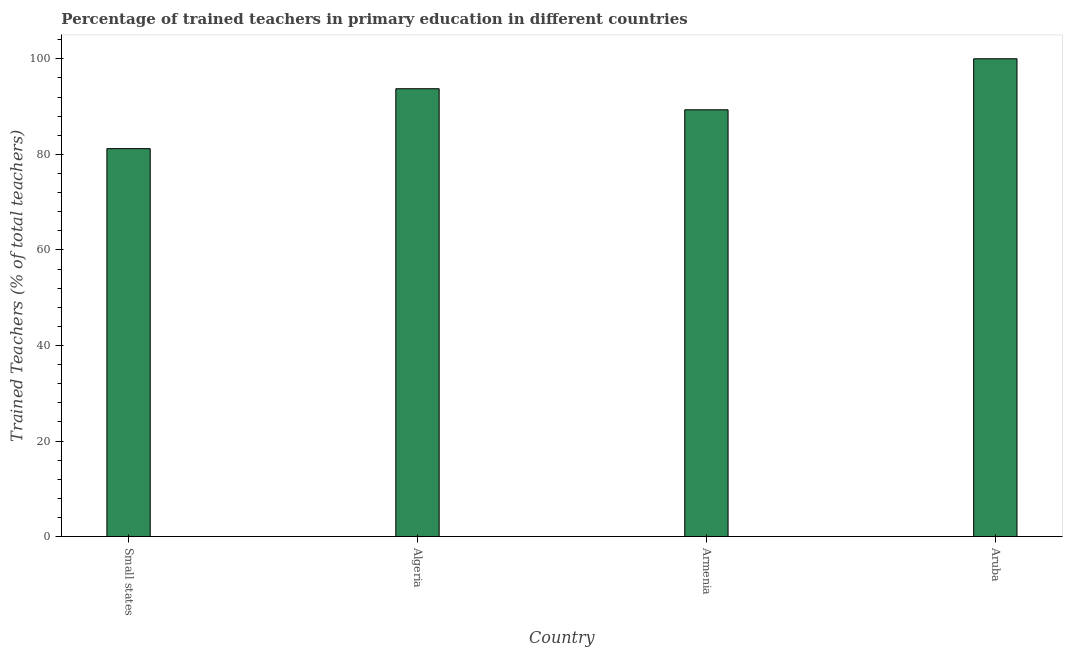Does the graph contain grids?
Your answer should be very brief. No. What is the title of the graph?
Offer a terse response. Percentage of trained teachers in primary education in different countries. What is the label or title of the Y-axis?
Ensure brevity in your answer.  Trained Teachers (% of total teachers). What is the percentage of trained teachers in Armenia?
Offer a very short reply. 89.33. Across all countries, what is the minimum percentage of trained teachers?
Make the answer very short. 81.19. In which country was the percentage of trained teachers maximum?
Offer a terse response. Aruba. In which country was the percentage of trained teachers minimum?
Offer a terse response. Small states. What is the sum of the percentage of trained teachers?
Offer a terse response. 364.25. What is the difference between the percentage of trained teachers in Armenia and Aruba?
Your answer should be very brief. -10.67. What is the average percentage of trained teachers per country?
Give a very brief answer. 91.06. What is the median percentage of trained teachers?
Ensure brevity in your answer.  91.53. What is the ratio of the percentage of trained teachers in Armenia to that in Aruba?
Ensure brevity in your answer.  0.89. What is the difference between the highest and the second highest percentage of trained teachers?
Make the answer very short. 6.27. Is the sum of the percentage of trained teachers in Algeria and Small states greater than the maximum percentage of trained teachers across all countries?
Offer a terse response. Yes. What is the difference between the highest and the lowest percentage of trained teachers?
Your answer should be compact. 18.81. In how many countries, is the percentage of trained teachers greater than the average percentage of trained teachers taken over all countries?
Your answer should be compact. 2. How many bars are there?
Your answer should be compact. 4. Are all the bars in the graph horizontal?
Give a very brief answer. No. How many countries are there in the graph?
Make the answer very short. 4. What is the Trained Teachers (% of total teachers) of Small states?
Ensure brevity in your answer.  81.19. What is the Trained Teachers (% of total teachers) in Algeria?
Provide a short and direct response. 93.73. What is the Trained Teachers (% of total teachers) of Armenia?
Provide a short and direct response. 89.33. What is the difference between the Trained Teachers (% of total teachers) in Small states and Algeria?
Offer a terse response. -12.53. What is the difference between the Trained Teachers (% of total teachers) in Small states and Armenia?
Offer a very short reply. -8.13. What is the difference between the Trained Teachers (% of total teachers) in Small states and Aruba?
Make the answer very short. -18.81. What is the difference between the Trained Teachers (% of total teachers) in Algeria and Armenia?
Ensure brevity in your answer.  4.4. What is the difference between the Trained Teachers (% of total teachers) in Algeria and Aruba?
Your answer should be compact. -6.27. What is the difference between the Trained Teachers (% of total teachers) in Armenia and Aruba?
Provide a succinct answer. -10.67. What is the ratio of the Trained Teachers (% of total teachers) in Small states to that in Algeria?
Ensure brevity in your answer.  0.87. What is the ratio of the Trained Teachers (% of total teachers) in Small states to that in Armenia?
Offer a very short reply. 0.91. What is the ratio of the Trained Teachers (% of total teachers) in Small states to that in Aruba?
Provide a short and direct response. 0.81. What is the ratio of the Trained Teachers (% of total teachers) in Algeria to that in Armenia?
Your answer should be very brief. 1.05. What is the ratio of the Trained Teachers (% of total teachers) in Algeria to that in Aruba?
Your answer should be very brief. 0.94. What is the ratio of the Trained Teachers (% of total teachers) in Armenia to that in Aruba?
Offer a very short reply. 0.89. 